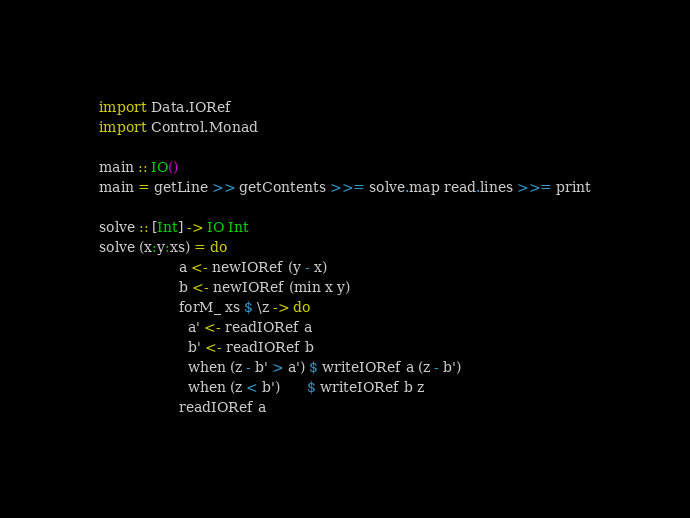<code> <loc_0><loc_0><loc_500><loc_500><_Haskell_>import Data.IORef
import Control.Monad
 
main :: IO()
main = getLine >> getContents >>= solve.map read.lines >>= print
 
solve :: [Int] -> IO Int
solve (x:y:xs) = do
                  a <- newIORef (y - x)
                  b <- newIORef (min x y)
                  forM_ xs $ \z -> do
                    a' <- readIORef a
                    b' <- readIORef b
                    when (z - b' > a') $ writeIORef a (z - b')
                    when (z < b')      $ writeIORef b z
                  readIORef a</code> 